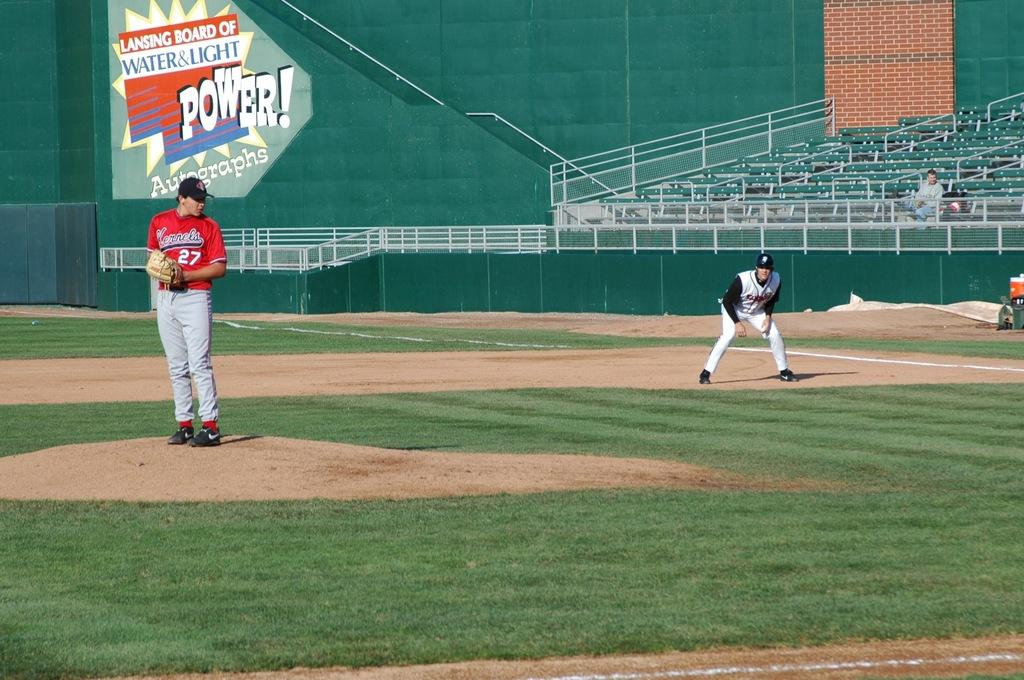Provide a one-sentence caption for the provided image. Baseball player in front of a sign Lansing Board of Water & Light. 